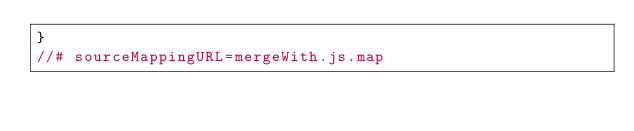Convert code to text. <code><loc_0><loc_0><loc_500><loc_500><_JavaScript_>}
//# sourceMappingURL=mergeWith.js.map</code> 